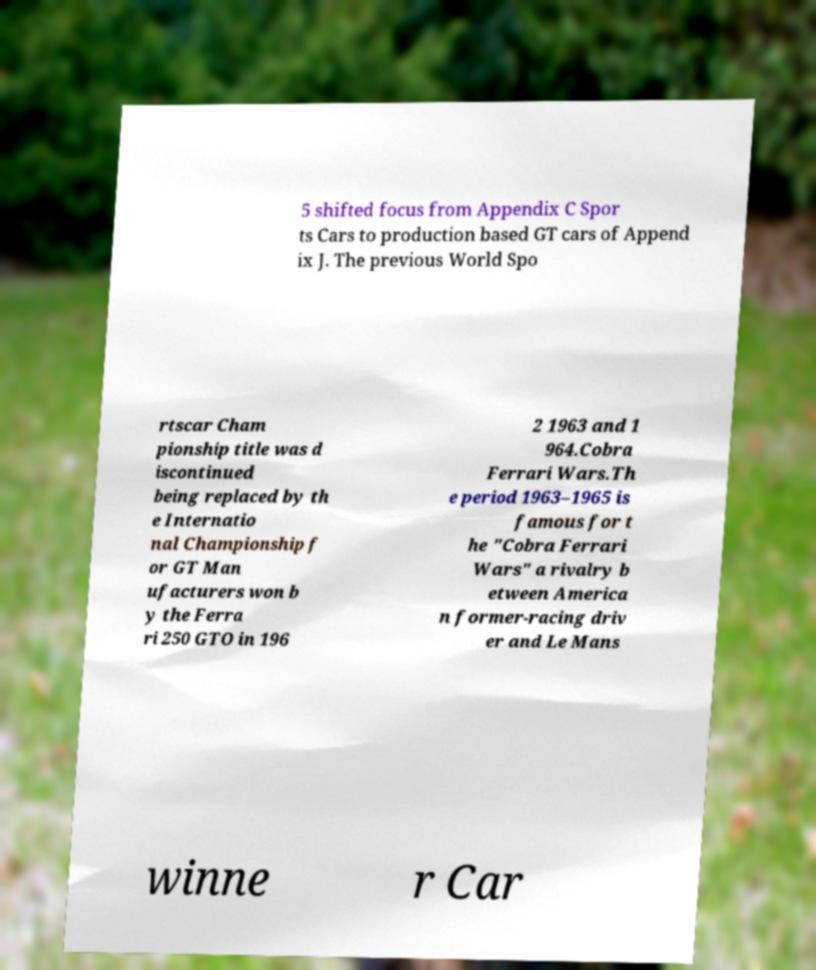Can you accurately transcribe the text from the provided image for me? 5 shifted focus from Appendix C Spor ts Cars to production based GT cars of Append ix J. The previous World Spo rtscar Cham pionship title was d iscontinued being replaced by th e Internatio nal Championship f or GT Man ufacturers won b y the Ferra ri 250 GTO in 196 2 1963 and 1 964.Cobra Ferrari Wars.Th e period 1963–1965 is famous for t he "Cobra Ferrari Wars" a rivalry b etween America n former-racing driv er and Le Mans winne r Car 